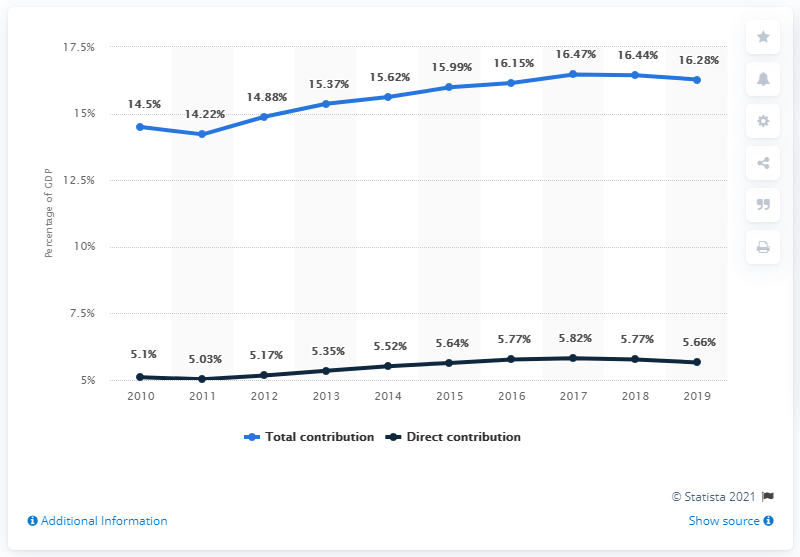Highlight a few significant elements in this photo. In 2019, the travel and tourism sector experienced a decline for the second consecutive year. The travel and tourism sector of the Dominican Republic began to grow in 2011. The first and last data points in the dark blue line are 0.56 and 0.56, respectively. The travel and tourism sector of the Dominican Republic has exceeded 16.15% of its GDP for three consecutive years. The highest percentage value in the blue line is 16.47%. 